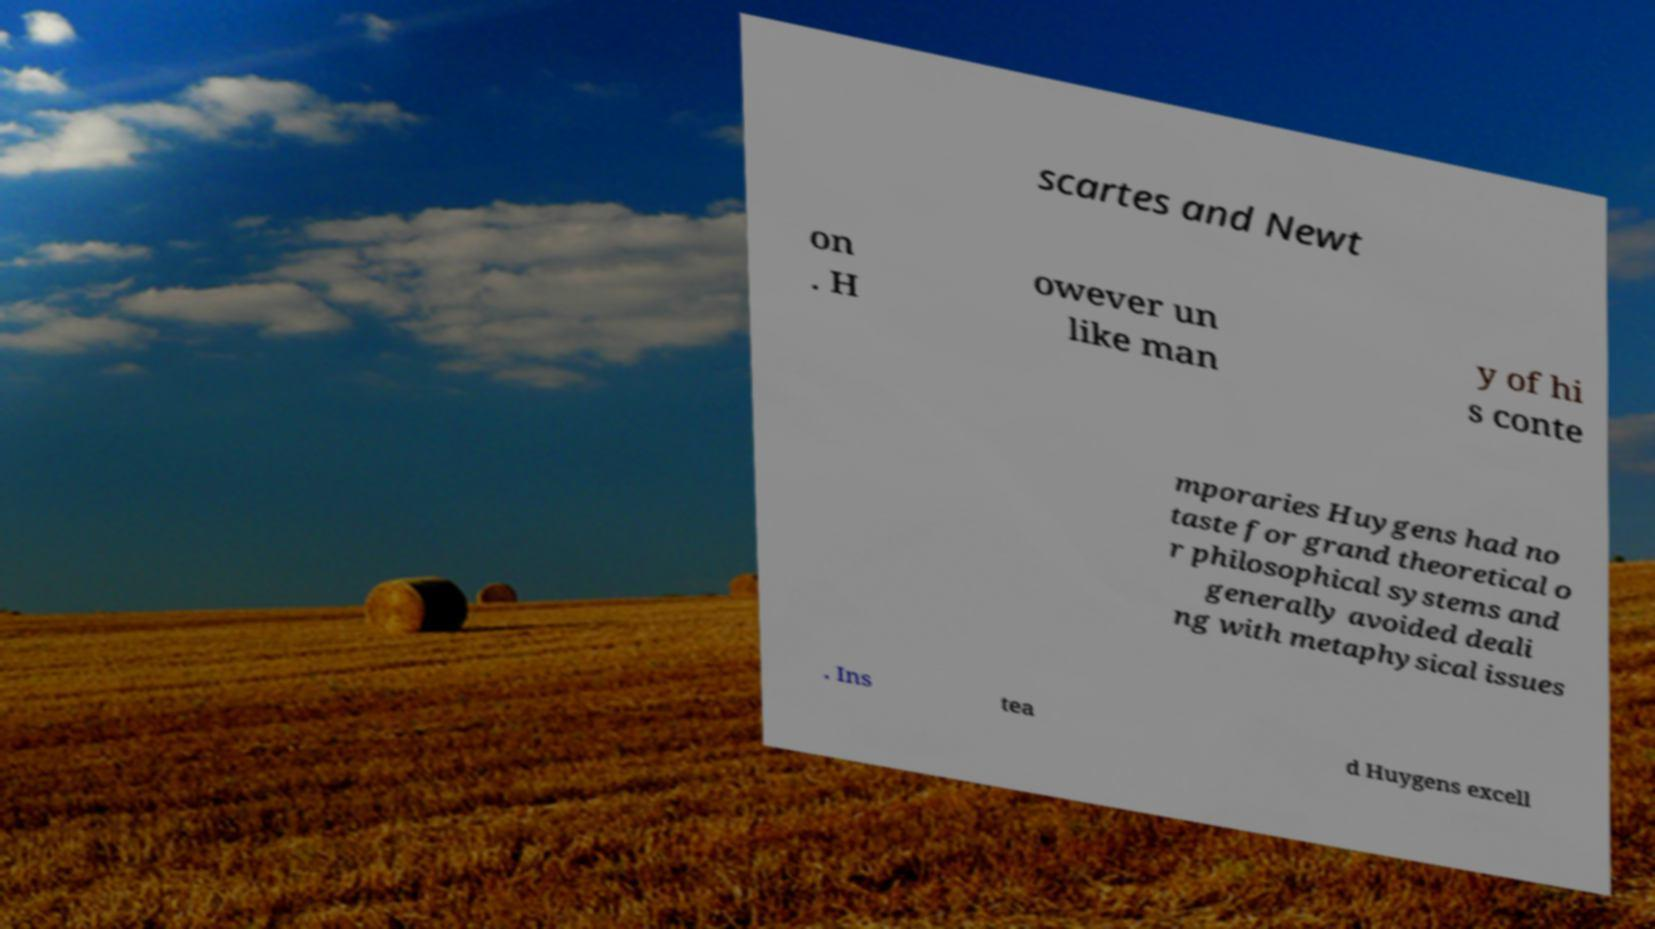What messages or text are displayed in this image? I need them in a readable, typed format. scartes and Newt on . H owever un like man y of hi s conte mporaries Huygens had no taste for grand theoretical o r philosophical systems and generally avoided deali ng with metaphysical issues . Ins tea d Huygens excell 